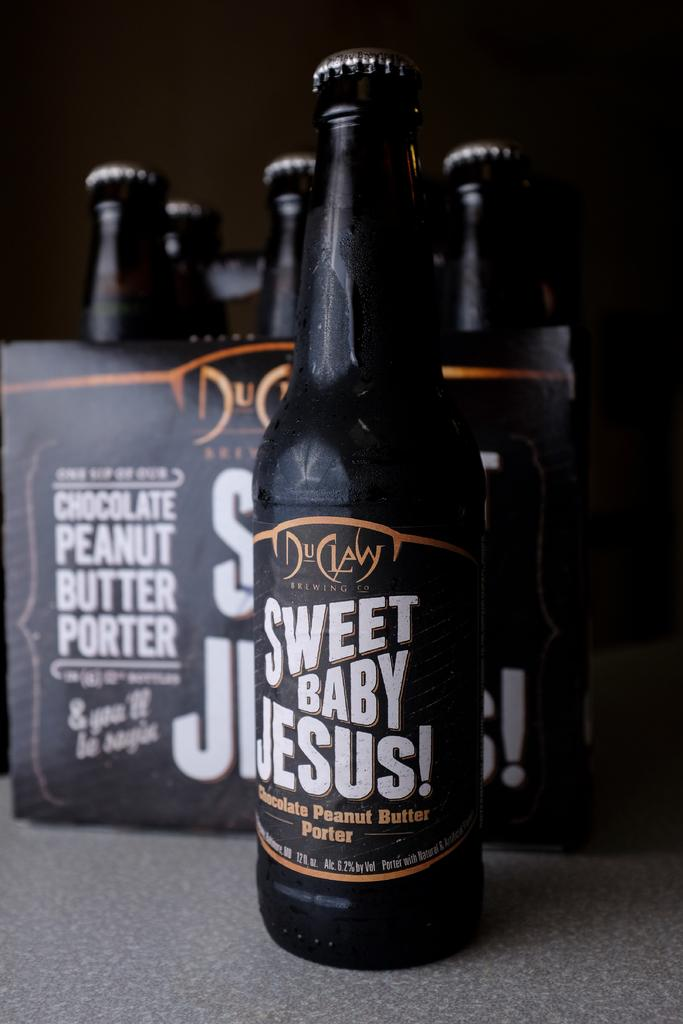<image>
Relay a brief, clear account of the picture shown. a Sweet Baby Jesus porter next to a six pack of the same 